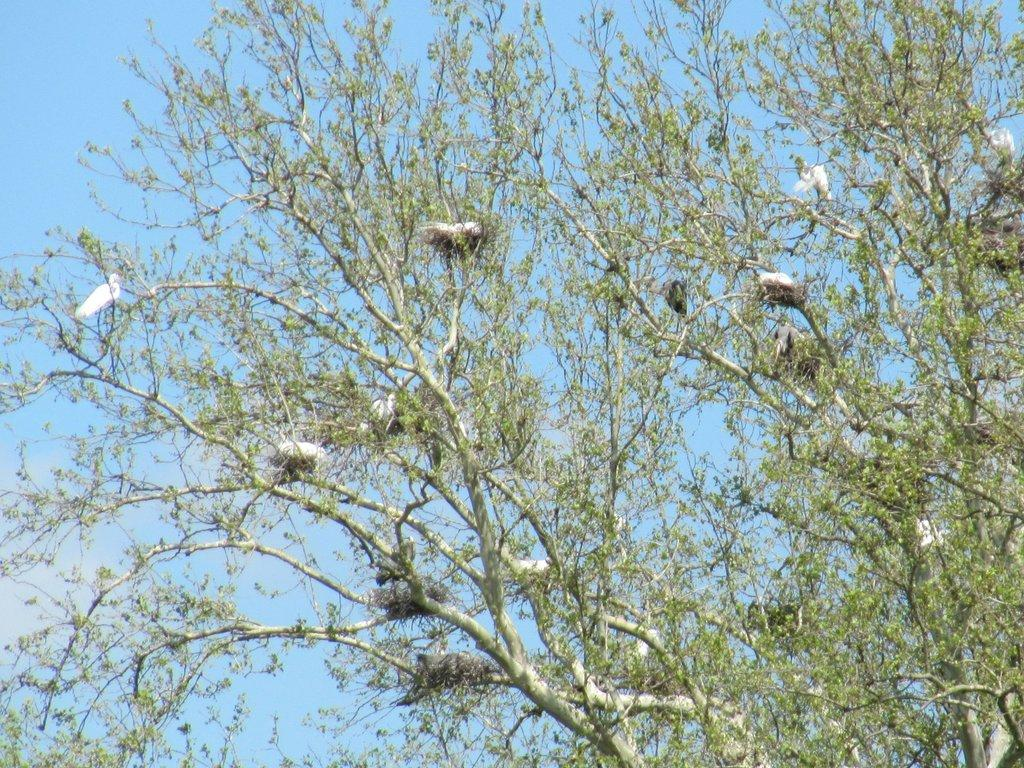What type of vegetation can be seen in the image? There are branches of trees in the image. What can be found on the branches of the trees? There are nests and birds on the branches. What is visible in the background of the image? The sky is visible in the background of the image. Can you tell me how many potatoes are present in the image? There are no potatoes present in the image; it features branches of trees with nests and birds. How many friends are visible in the image? There is no reference to friends in the image; it focuses on branches, nests, birds, and the sky. 